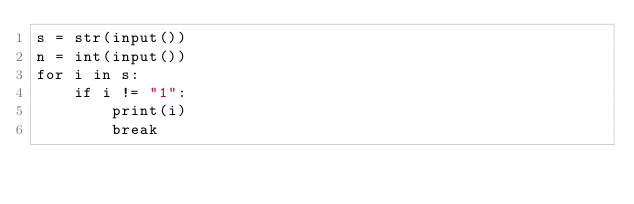<code> <loc_0><loc_0><loc_500><loc_500><_Python_>s = str(input())
n = int(input())
for i in s:
    if i != "1":
        print(i)
        break</code> 